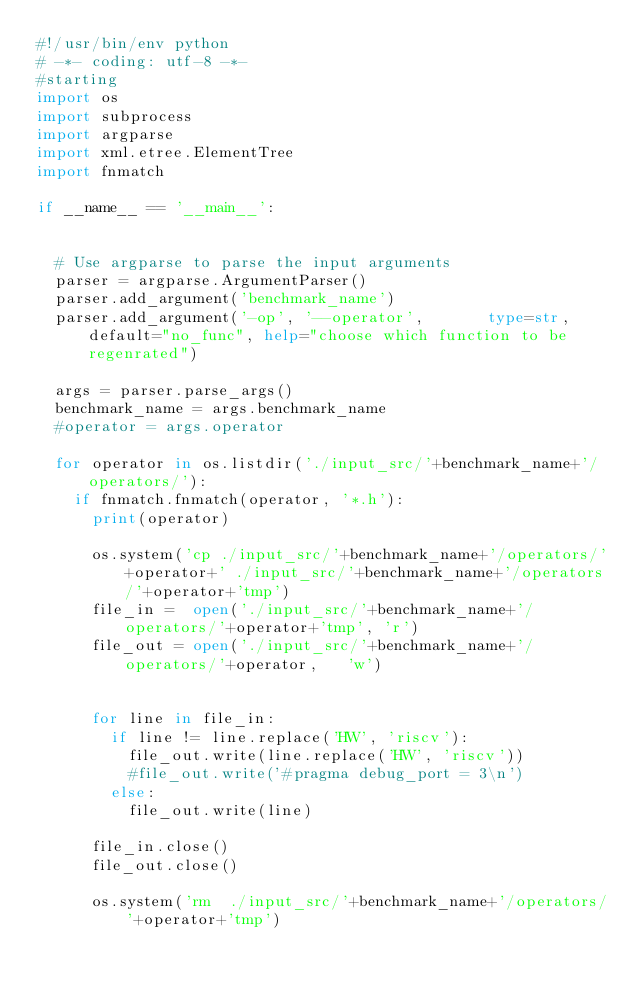Convert code to text. <code><loc_0><loc_0><loc_500><loc_500><_Python_>#!/usr/bin/env python
# -*- coding: utf-8 -*-   
#starting
import os  
import subprocess
import argparse
import xml.etree.ElementTree
import fnmatch

if __name__ == '__main__':


  # Use argparse to parse the input arguments
  parser = argparse.ArgumentParser()
  parser.add_argument('benchmark_name')
  parser.add_argument('-op', '--operator',       type=str, default="no_func", help="choose which function to be regenrated")

  args = parser.parse_args()
  benchmark_name = args.benchmark_name  
  #operator = args.operator

  for operator in os.listdir('./input_src/'+benchmark_name+'/operators/'):
    if fnmatch.fnmatch(operator, '*.h'):
      print(operator)

      os.system('cp ./input_src/'+benchmark_name+'/operators/'+operator+' ./input_src/'+benchmark_name+'/operators/'+operator+'tmp')
      file_in =  open('./input_src/'+benchmark_name+'/operators/'+operator+'tmp', 'r')
      file_out = open('./input_src/'+benchmark_name+'/operators/'+operator,   'w')


      for line in file_in:
        if line != line.replace('HW', 'riscv'):
          file_out.write(line.replace('HW', 'riscv'))
          #file_out.write('#pragma debug_port = 3\n')
        else:
          file_out.write(line)

      file_in.close()
      file_out.close()

      os.system('rm  ./input_src/'+benchmark_name+'/operators/'+operator+'tmp')
</code> 